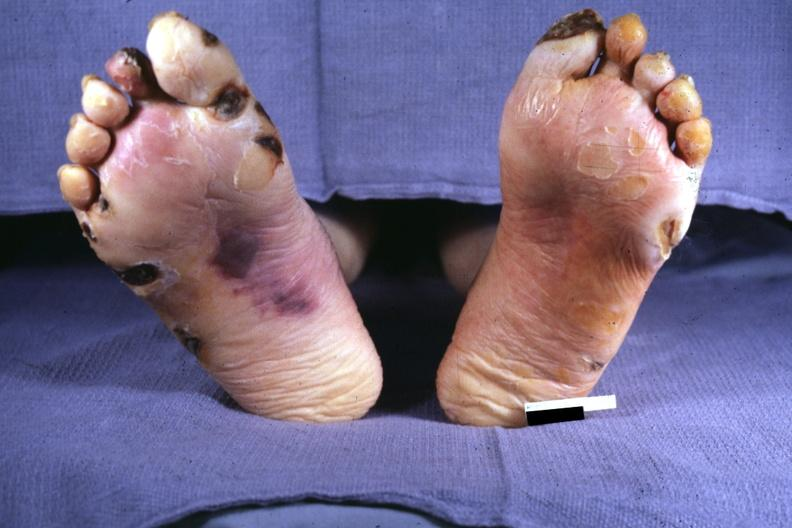re extremities present?
Answer the question using a single word or phrase. Yes 